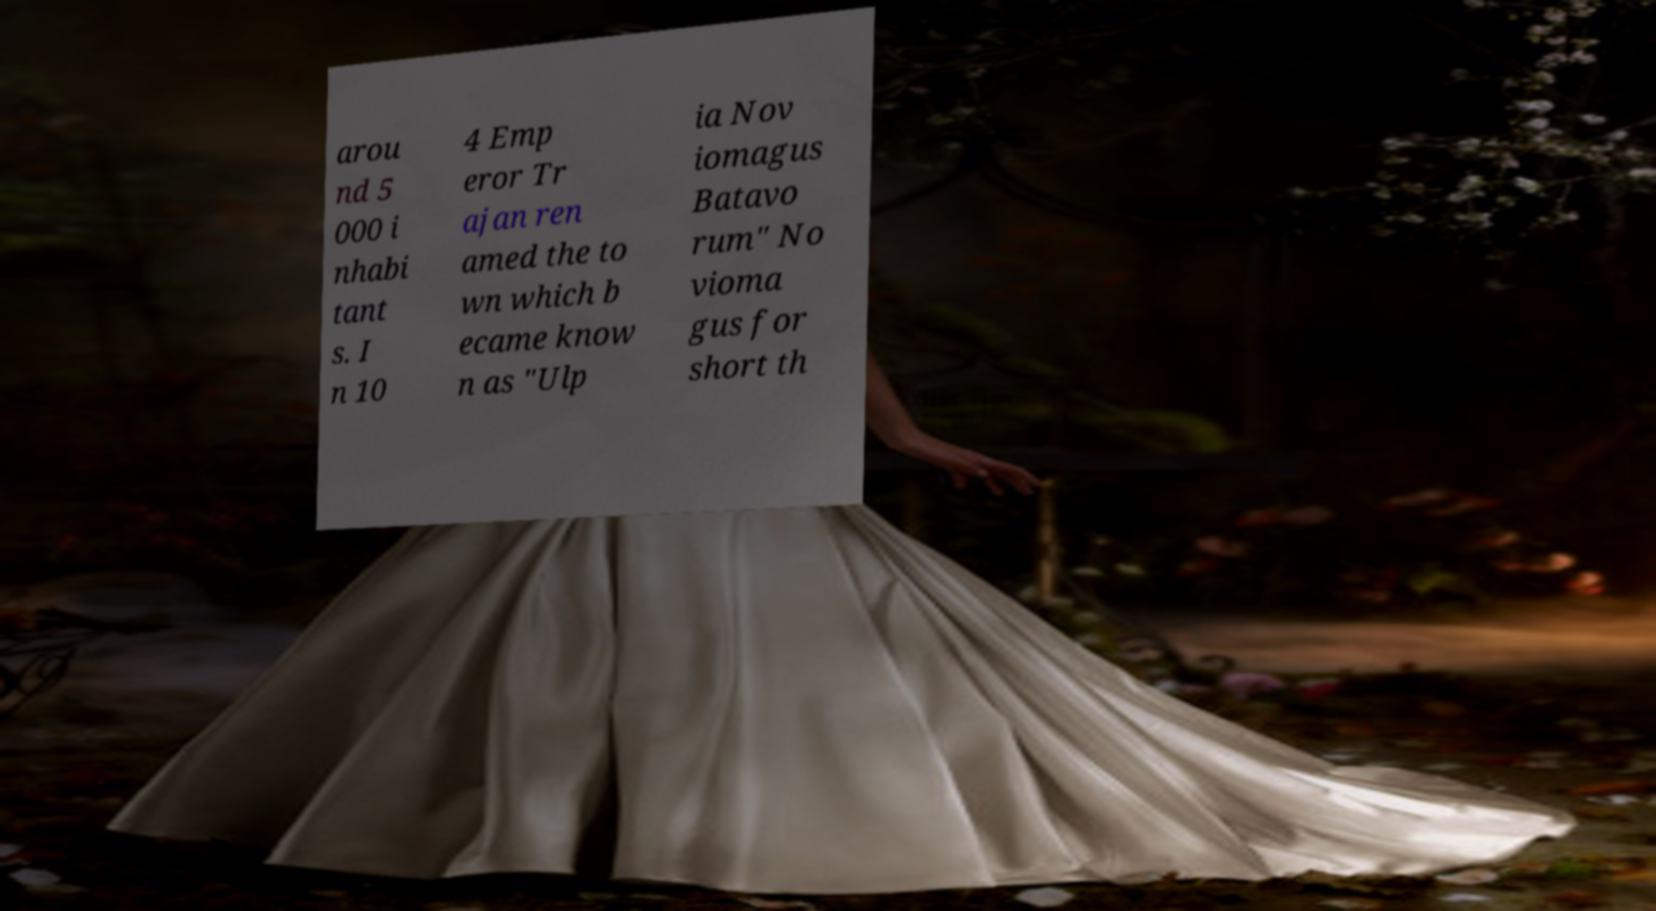Can you accurately transcribe the text from the provided image for me? arou nd 5 000 i nhabi tant s. I n 10 4 Emp eror Tr ajan ren amed the to wn which b ecame know n as "Ulp ia Nov iomagus Batavo rum" No vioma gus for short th 